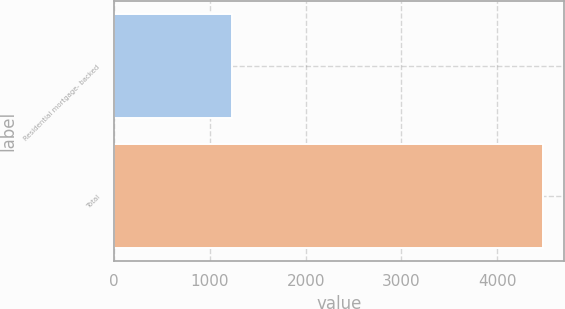<chart> <loc_0><loc_0><loc_500><loc_500><bar_chart><fcel>Residential mortgage- backed<fcel>Total<nl><fcel>1231<fcel>4473<nl></chart> 